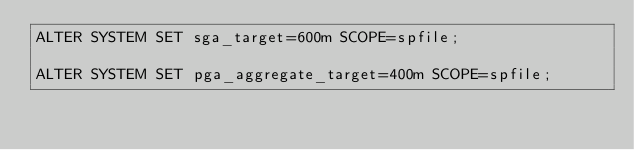<code> <loc_0><loc_0><loc_500><loc_500><_SQL_>ALTER SYSTEM SET sga_target=600m SCOPE=spfile;

ALTER SYSTEM SET pga_aggregate_target=400m SCOPE=spfile;
</code> 